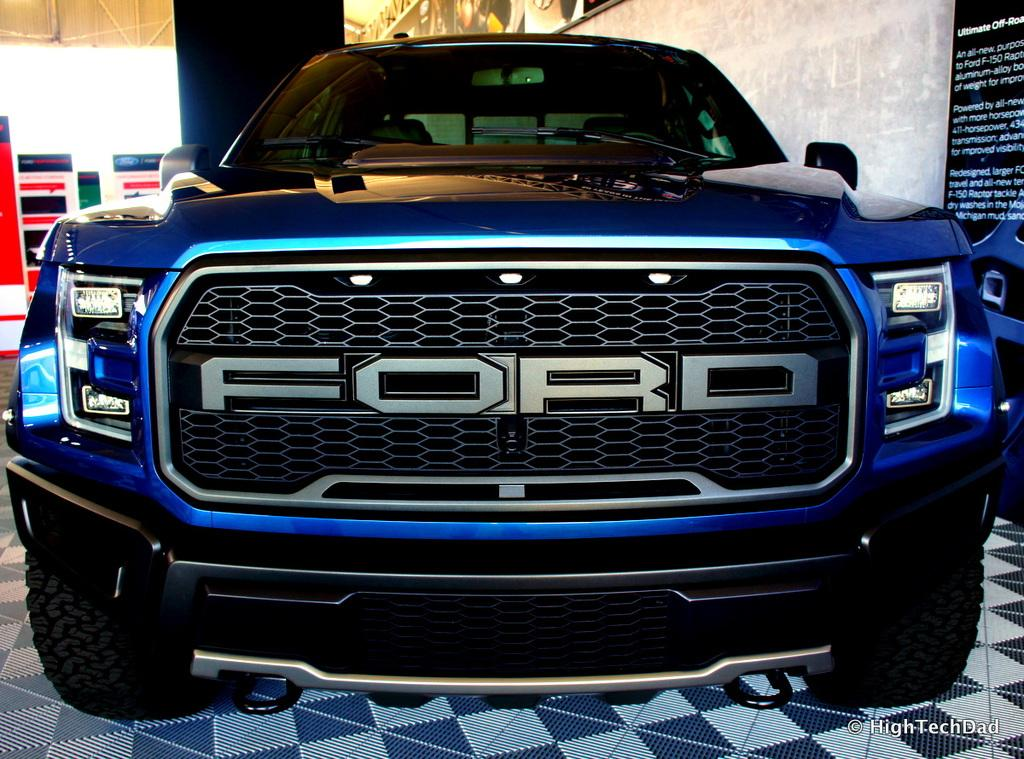What is the main subject of the picture? There is a vehicle in the picture. What can be seen in the background of the picture? There are banners and a board attached to the wall in the background of the picture. Is there any text or logo visible on the image? Yes, there is a watermark on the image. What type of wool can be seen being twisted in the yard in the image? There is no wool or yard present in the image; it features a vehicle and background elements. 